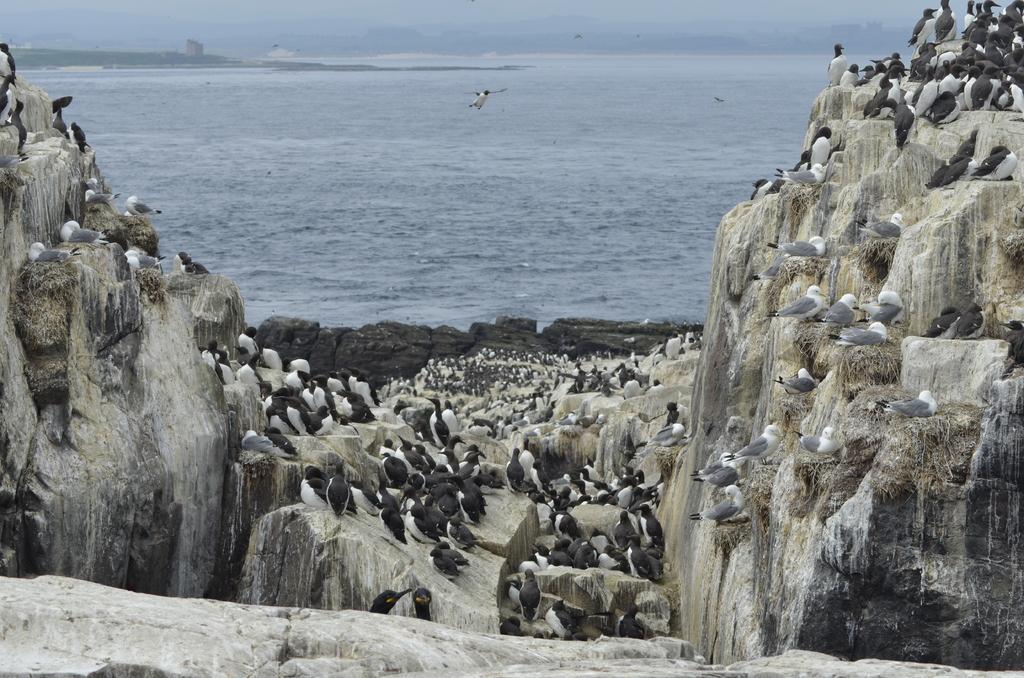Please provide a concise description of this image. In this picture we can observe number of penguins on the rocks. On either sides of this picture we can observe two hills. In the background there is an ocean. 